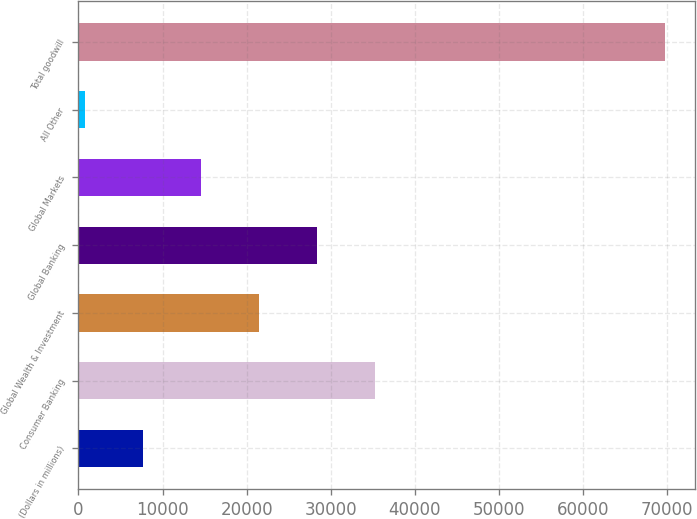Convert chart. <chart><loc_0><loc_0><loc_500><loc_500><bar_chart><fcel>(Dollars in millions)<fcel>Consumer Banking<fcel>Global Wealth & Investment<fcel>Global Banking<fcel>Global Markets<fcel>All Other<fcel>Total goodwill<nl><fcel>7714.1<fcel>35290.5<fcel>21502.3<fcel>28396.4<fcel>14608.2<fcel>820<fcel>69761<nl></chart> 